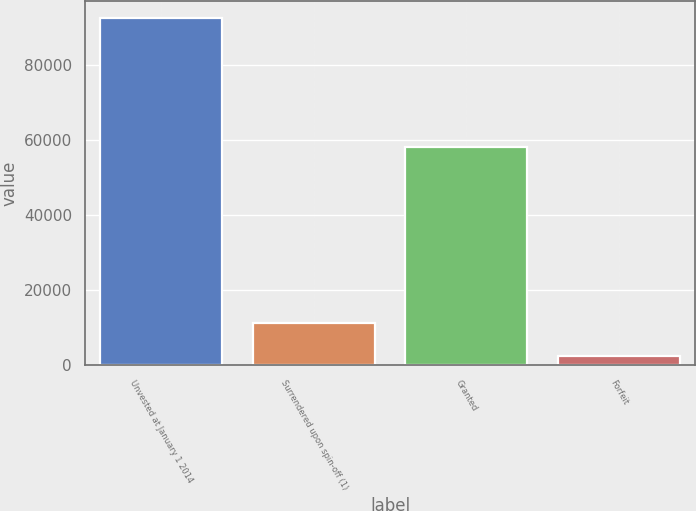Convert chart. <chart><loc_0><loc_0><loc_500><loc_500><bar_chart><fcel>Unvested at January 1 2014<fcel>Surrendered upon spin-off (1)<fcel>Granted<fcel>Forfeit<nl><fcel>92545<fcel>11397.4<fcel>58206<fcel>2381<nl></chart> 